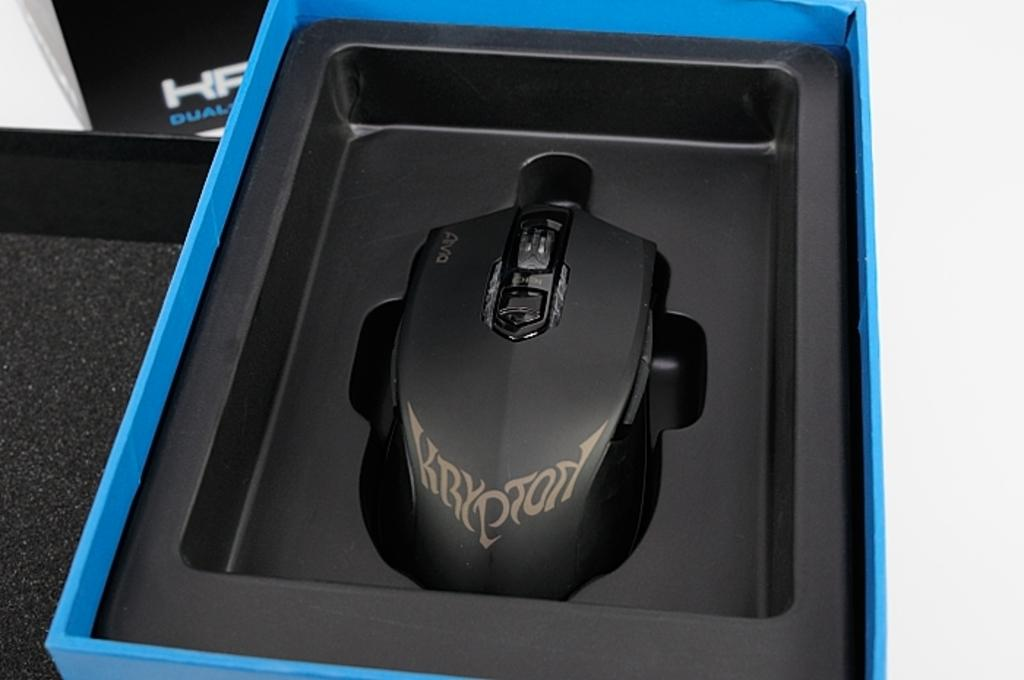What is the main object in the image? There is a gaming mouse in the image. Where is the gaming mouse located? The gaming mouse is in a box. What can be found on the box besides the gaming mouse? There is text on the box. Can you describe the location of the text on the box? The text is on the left side top of the box. How does the gaming mouse show support for the flag in the image? There is no flag present in the image, and the gaming mouse does not show support for any flag. 